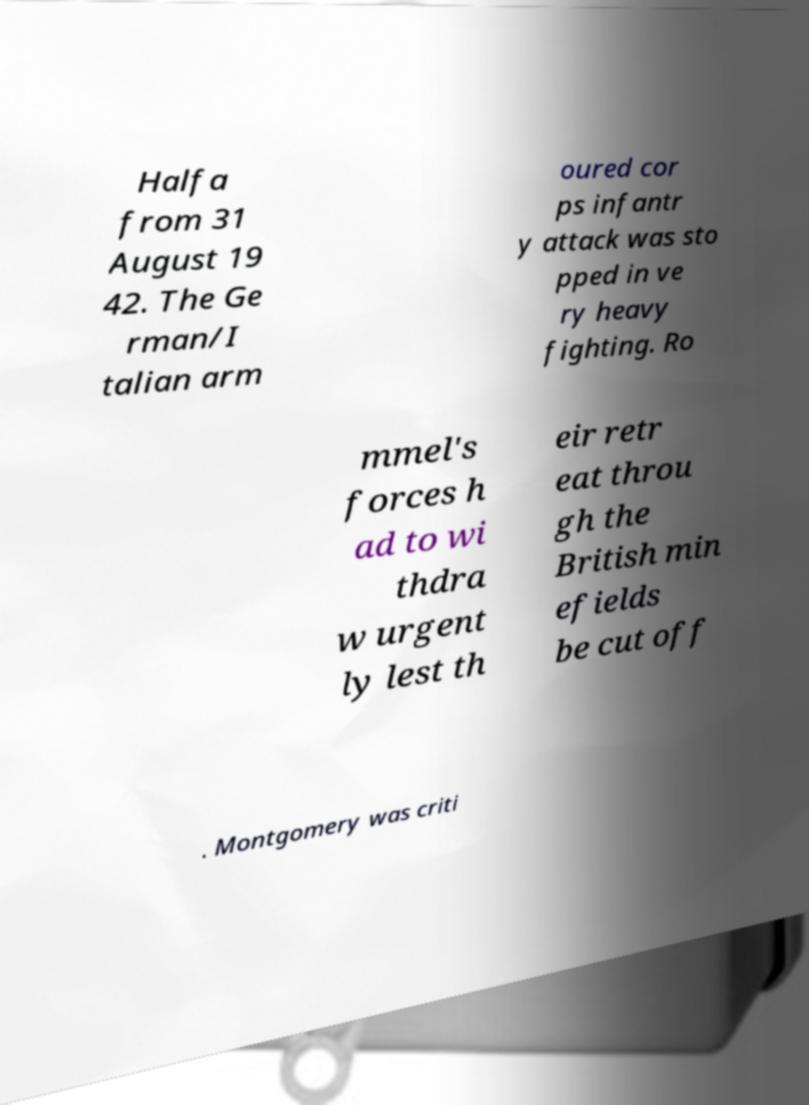What messages or text are displayed in this image? I need them in a readable, typed format. Halfa from 31 August 19 42. The Ge rman/I talian arm oured cor ps infantr y attack was sto pped in ve ry heavy fighting. Ro mmel's forces h ad to wi thdra w urgent ly lest th eir retr eat throu gh the British min efields be cut off . Montgomery was criti 